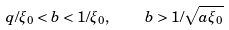Convert formula to latex. <formula><loc_0><loc_0><loc_500><loc_500>q / \xi _ { 0 } < b < 1 / \xi _ { 0 } , \quad b > 1 / \sqrt { a \xi _ { 0 } }</formula> 